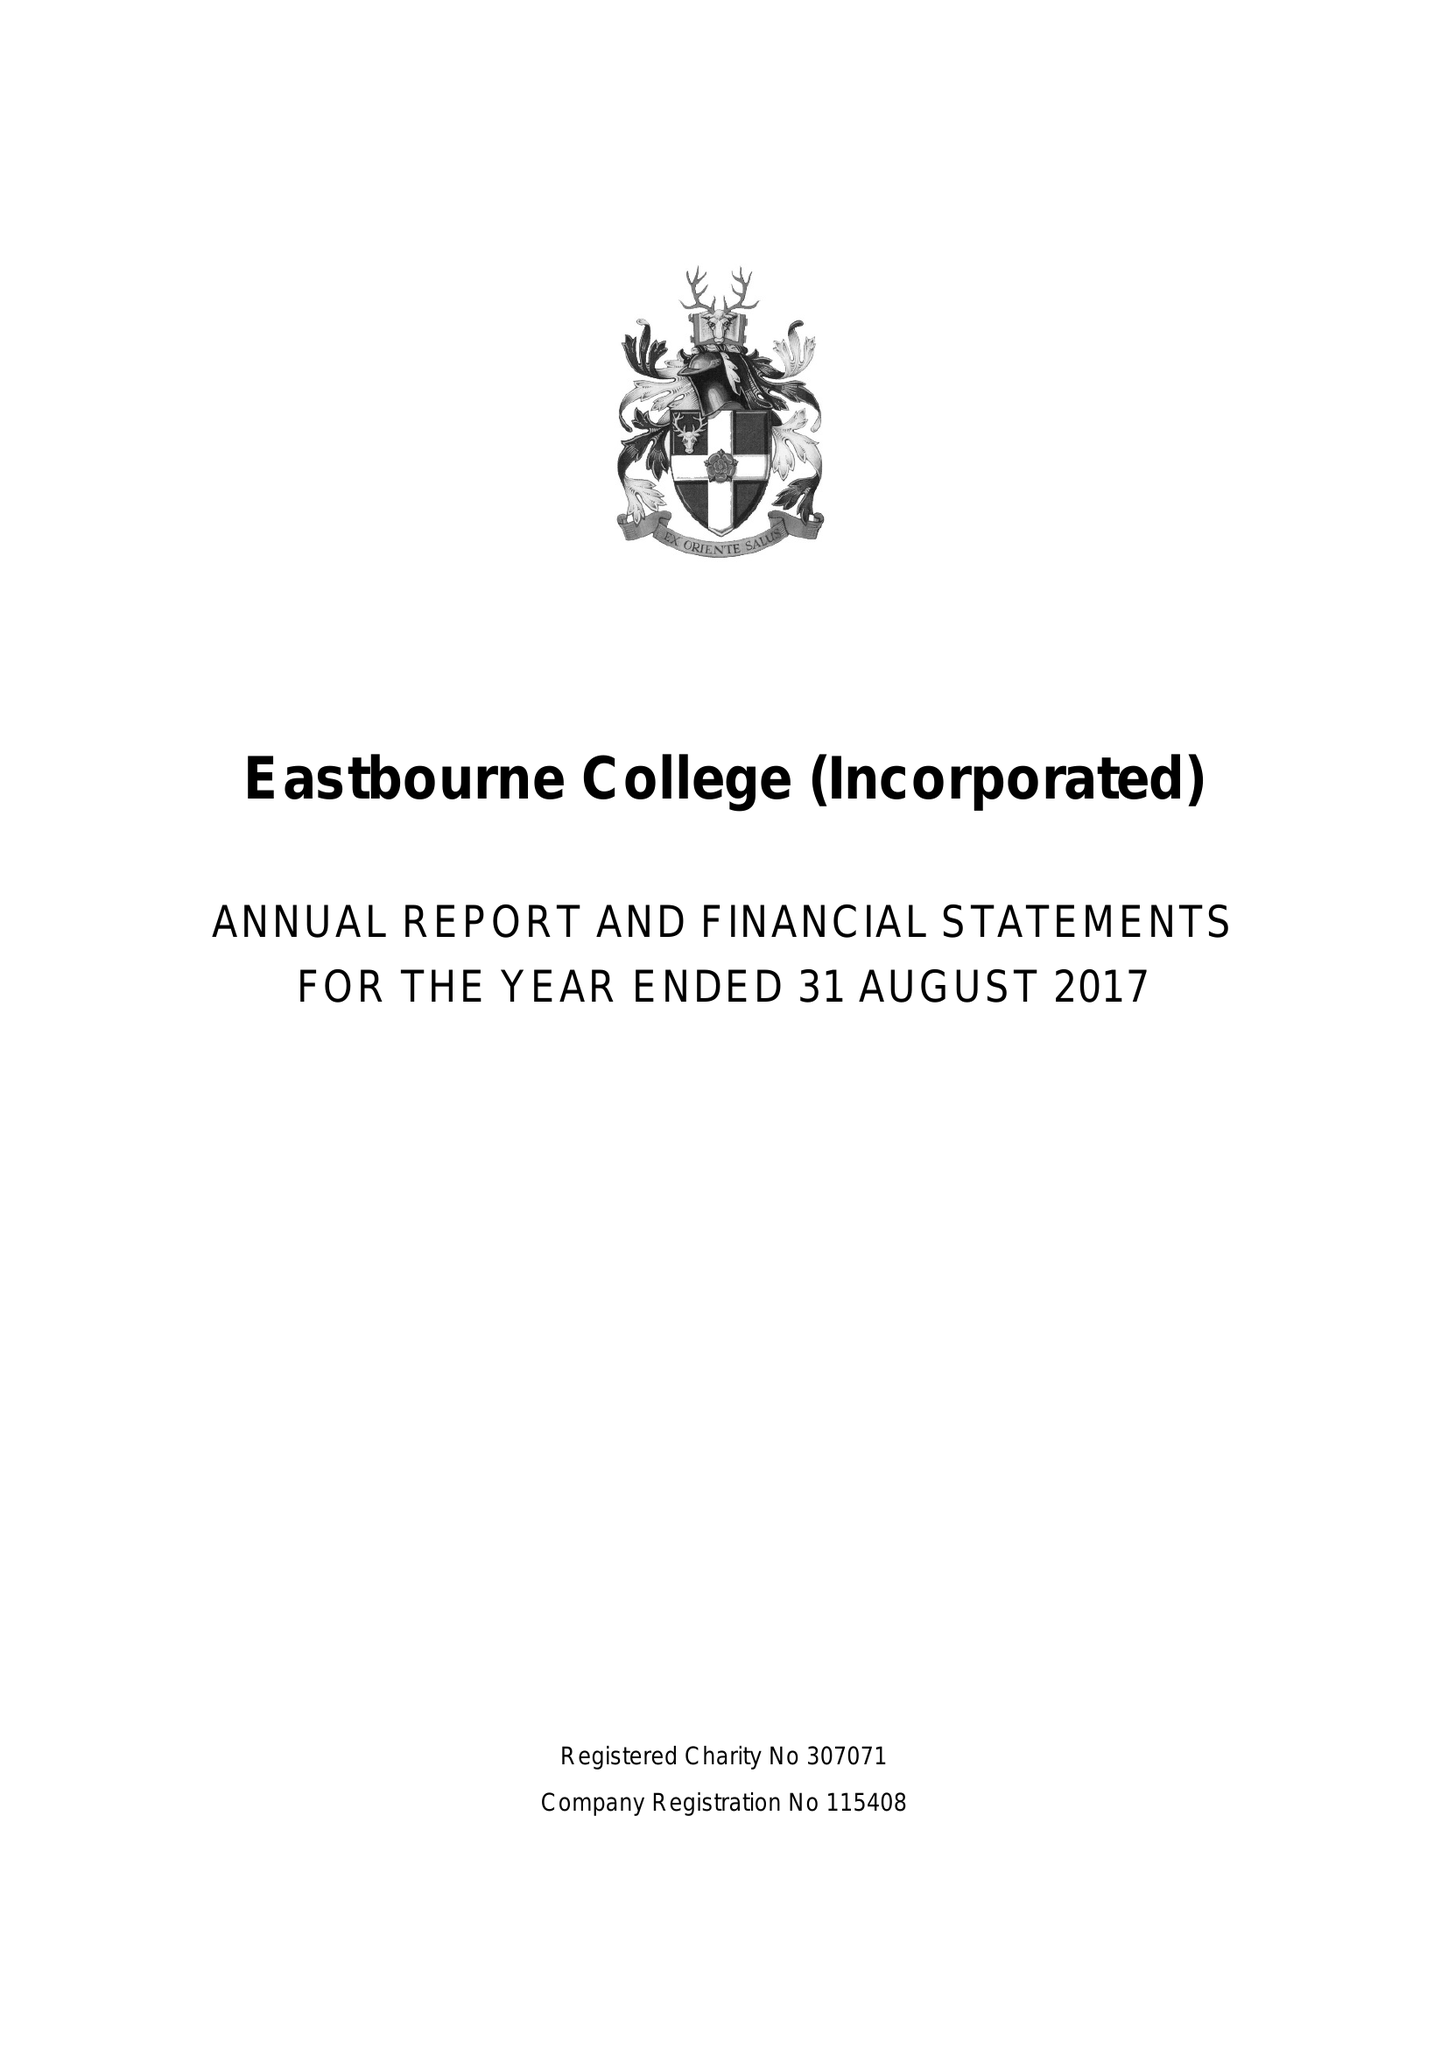What is the value for the spending_annually_in_british_pounds?
Answer the question using a single word or phrase. 20428000.00 